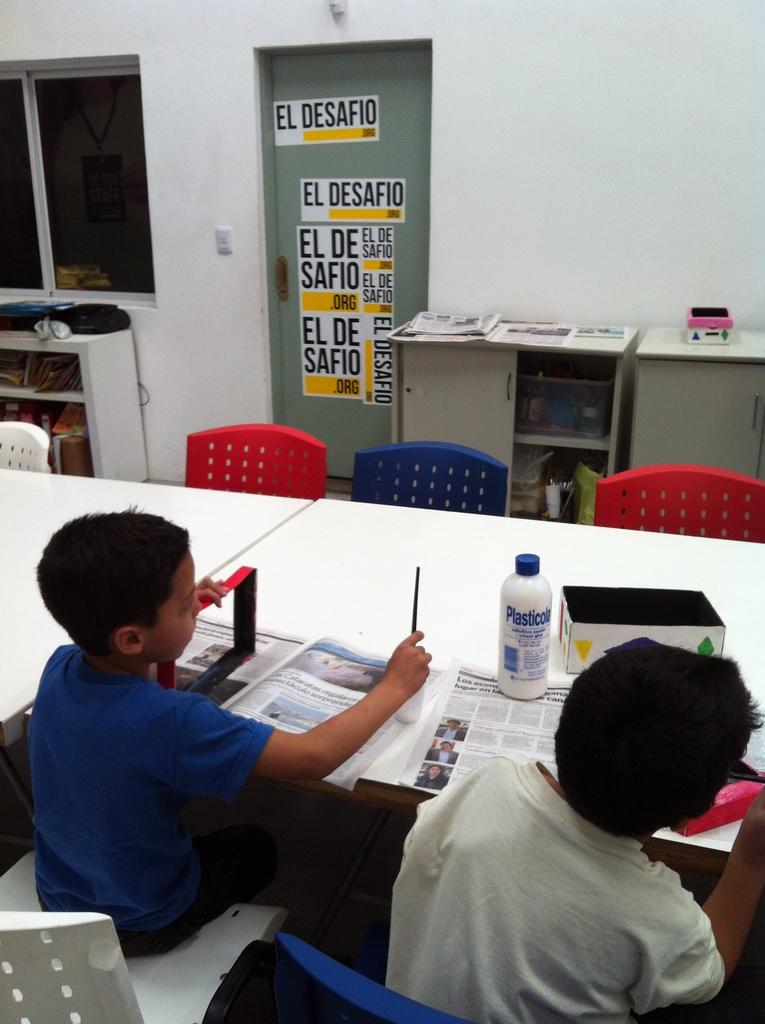What is the brand on the bottle?
Keep it short and to the point. Plasticola. What words are repeated on the door?
Provide a short and direct response. El desafio. 